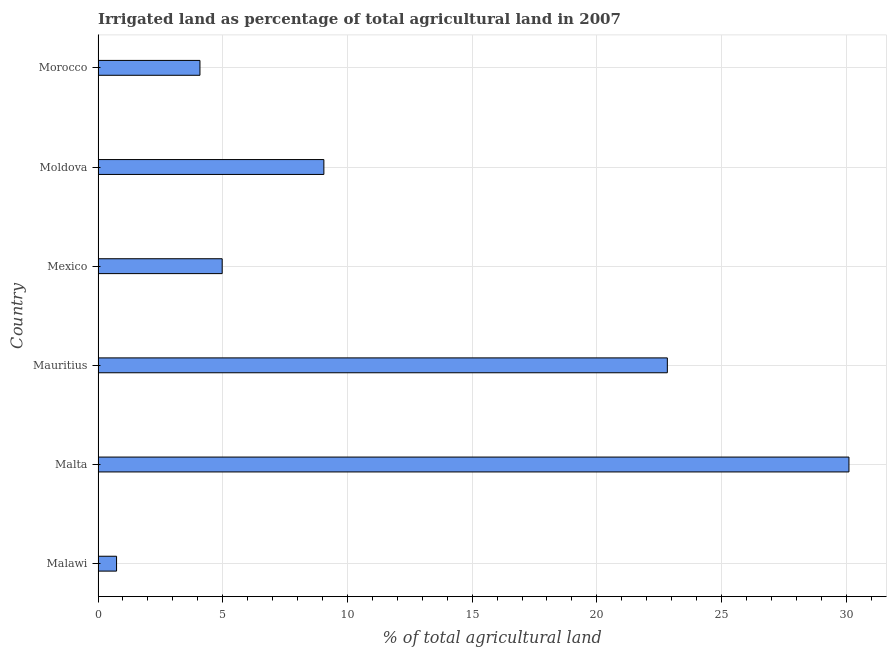Does the graph contain grids?
Your answer should be compact. Yes. What is the title of the graph?
Provide a short and direct response. Irrigated land as percentage of total agricultural land in 2007. What is the label or title of the X-axis?
Your answer should be compact. % of total agricultural land. What is the label or title of the Y-axis?
Give a very brief answer. Country. What is the percentage of agricultural irrigated land in Malawi?
Offer a terse response. 0.74. Across all countries, what is the maximum percentage of agricultural irrigated land?
Your answer should be very brief. 30.11. Across all countries, what is the minimum percentage of agricultural irrigated land?
Keep it short and to the point. 0.74. In which country was the percentage of agricultural irrigated land maximum?
Provide a short and direct response. Malta. In which country was the percentage of agricultural irrigated land minimum?
Provide a short and direct response. Malawi. What is the sum of the percentage of agricultural irrigated land?
Your response must be concise. 71.79. What is the difference between the percentage of agricultural irrigated land in Mauritius and Morocco?
Give a very brief answer. 18.74. What is the average percentage of agricultural irrigated land per country?
Make the answer very short. 11.97. What is the median percentage of agricultural irrigated land?
Offer a terse response. 7.02. In how many countries, is the percentage of agricultural irrigated land greater than 9 %?
Provide a succinct answer. 3. What is the ratio of the percentage of agricultural irrigated land in Mexico to that in Moldova?
Offer a terse response. 0.55. Is the percentage of agricultural irrigated land in Malta less than that in Mexico?
Offer a very short reply. No. What is the difference between the highest and the second highest percentage of agricultural irrigated land?
Keep it short and to the point. 7.28. Is the sum of the percentage of agricultural irrigated land in Malta and Morocco greater than the maximum percentage of agricultural irrigated land across all countries?
Your response must be concise. Yes. What is the difference between the highest and the lowest percentage of agricultural irrigated land?
Your response must be concise. 29.37. In how many countries, is the percentage of agricultural irrigated land greater than the average percentage of agricultural irrigated land taken over all countries?
Make the answer very short. 2. How many bars are there?
Your response must be concise. 6. How many countries are there in the graph?
Keep it short and to the point. 6. What is the difference between two consecutive major ticks on the X-axis?
Offer a very short reply. 5. Are the values on the major ticks of X-axis written in scientific E-notation?
Make the answer very short. No. What is the % of total agricultural land of Malawi?
Ensure brevity in your answer.  0.74. What is the % of total agricultural land of Malta?
Keep it short and to the point. 30.11. What is the % of total agricultural land in Mauritius?
Offer a terse response. 22.83. What is the % of total agricultural land of Mexico?
Provide a short and direct response. 4.98. What is the % of total agricultural land in Moldova?
Provide a short and direct response. 9.05. What is the % of total agricultural land of Morocco?
Your answer should be very brief. 4.09. What is the difference between the % of total agricultural land in Malawi and Malta?
Your response must be concise. -29.37. What is the difference between the % of total agricultural land in Malawi and Mauritius?
Offer a terse response. -22.08. What is the difference between the % of total agricultural land in Malawi and Mexico?
Offer a very short reply. -4.24. What is the difference between the % of total agricultural land in Malawi and Moldova?
Offer a terse response. -8.31. What is the difference between the % of total agricultural land in Malawi and Morocco?
Provide a succinct answer. -3.34. What is the difference between the % of total agricultural land in Malta and Mauritius?
Offer a terse response. 7.28. What is the difference between the % of total agricultural land in Malta and Mexico?
Give a very brief answer. 25.13. What is the difference between the % of total agricultural land in Malta and Moldova?
Offer a terse response. 21.05. What is the difference between the % of total agricultural land in Malta and Morocco?
Offer a very short reply. 26.02. What is the difference between the % of total agricultural land in Mauritius and Mexico?
Provide a short and direct response. 17.85. What is the difference between the % of total agricultural land in Mauritius and Moldova?
Provide a short and direct response. 13.77. What is the difference between the % of total agricultural land in Mauritius and Morocco?
Keep it short and to the point. 18.74. What is the difference between the % of total agricultural land in Mexico and Moldova?
Your answer should be very brief. -4.08. What is the difference between the % of total agricultural land in Mexico and Morocco?
Offer a terse response. 0.89. What is the difference between the % of total agricultural land in Moldova and Morocco?
Provide a succinct answer. 4.97. What is the ratio of the % of total agricultural land in Malawi to that in Malta?
Provide a short and direct response. 0.03. What is the ratio of the % of total agricultural land in Malawi to that in Mauritius?
Provide a short and direct response. 0.03. What is the ratio of the % of total agricultural land in Malawi to that in Mexico?
Ensure brevity in your answer.  0.15. What is the ratio of the % of total agricultural land in Malawi to that in Moldova?
Your answer should be very brief. 0.08. What is the ratio of the % of total agricultural land in Malawi to that in Morocco?
Offer a very short reply. 0.18. What is the ratio of the % of total agricultural land in Malta to that in Mauritius?
Your answer should be compact. 1.32. What is the ratio of the % of total agricultural land in Malta to that in Mexico?
Keep it short and to the point. 6.05. What is the ratio of the % of total agricultural land in Malta to that in Moldova?
Your answer should be compact. 3.33. What is the ratio of the % of total agricultural land in Malta to that in Morocco?
Keep it short and to the point. 7.37. What is the ratio of the % of total agricultural land in Mauritius to that in Mexico?
Make the answer very short. 4.59. What is the ratio of the % of total agricultural land in Mauritius to that in Moldova?
Your answer should be compact. 2.52. What is the ratio of the % of total agricultural land in Mauritius to that in Morocco?
Your answer should be compact. 5.59. What is the ratio of the % of total agricultural land in Mexico to that in Moldova?
Provide a succinct answer. 0.55. What is the ratio of the % of total agricultural land in Mexico to that in Morocco?
Ensure brevity in your answer.  1.22. What is the ratio of the % of total agricultural land in Moldova to that in Morocco?
Offer a very short reply. 2.22. 